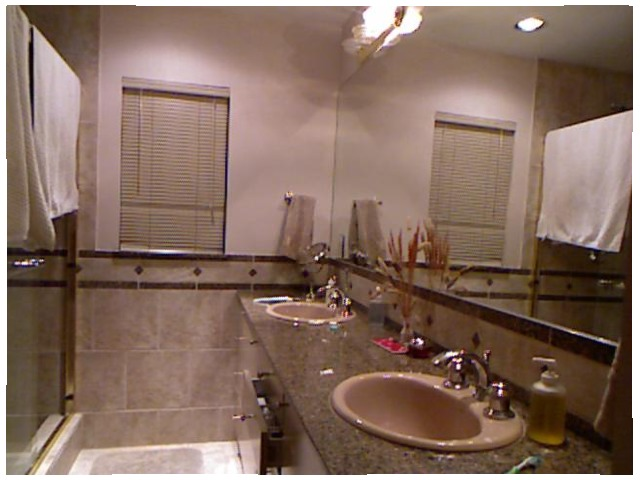<image>
Can you confirm if the towel is in the mirror? No. The towel is not contained within the mirror. These objects have a different spatial relationship. Is there a tap next to the table? No. The tap is not positioned next to the table. They are located in different areas of the scene. 